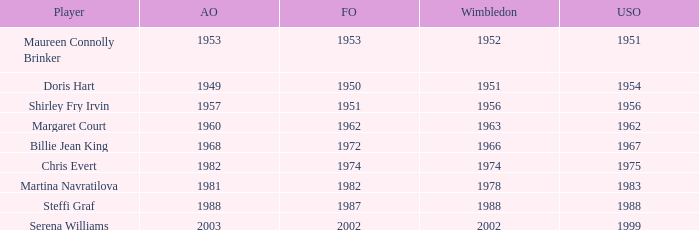When did Shirley Fry Irvin win the US Open? 1956.0. 